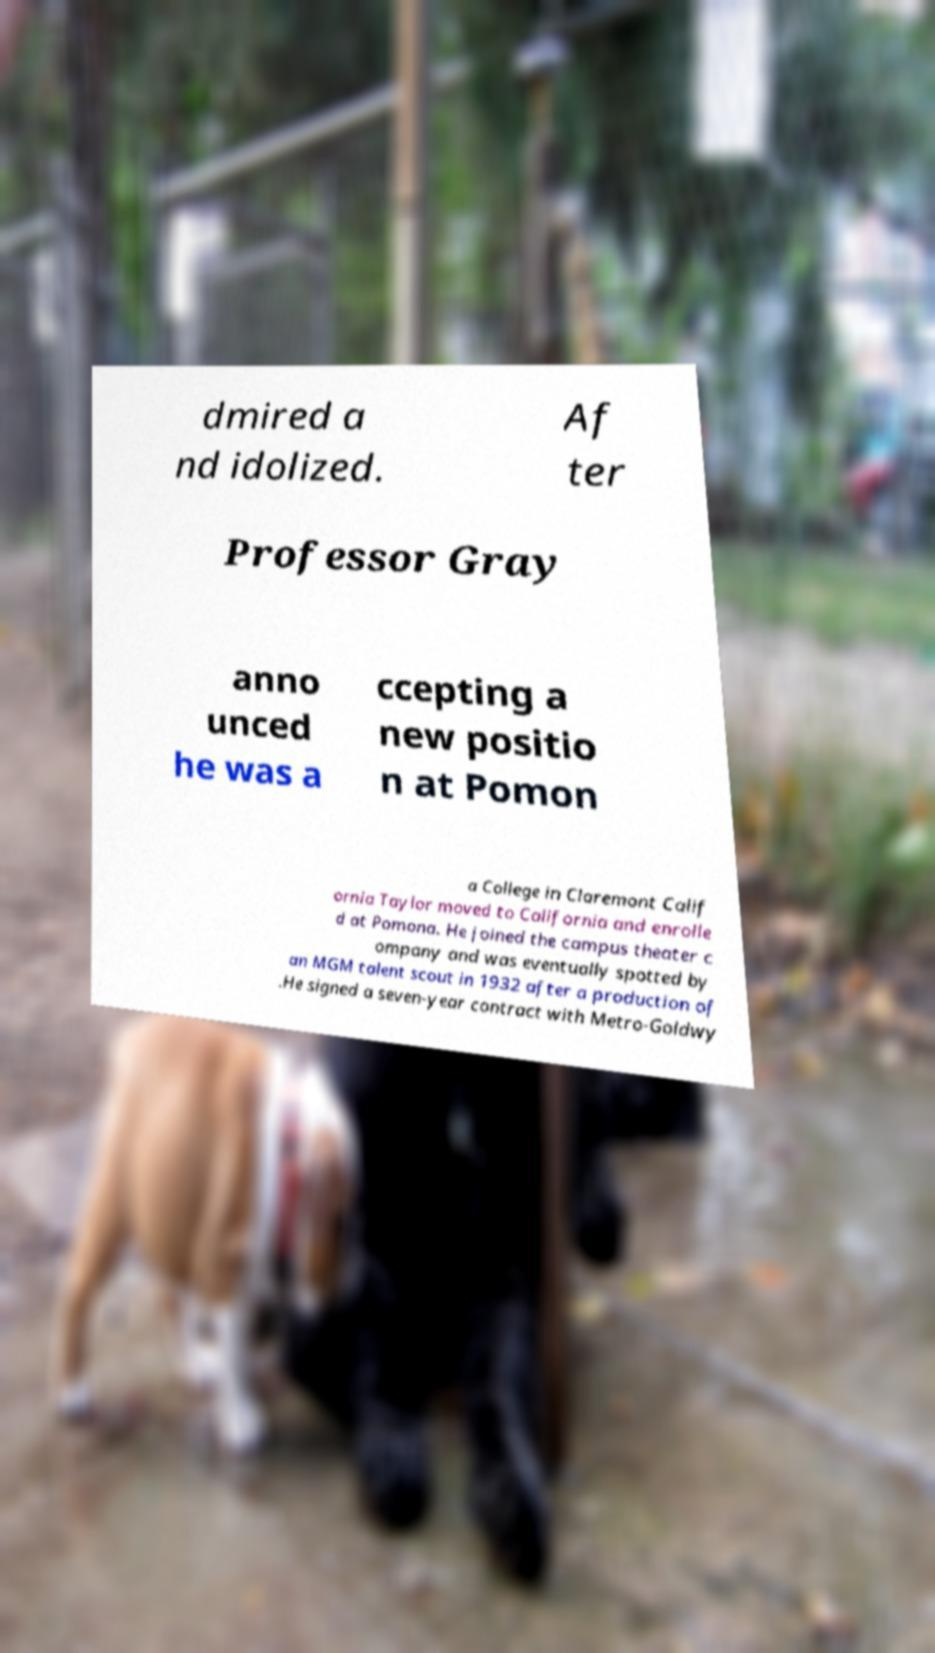There's text embedded in this image that I need extracted. Can you transcribe it verbatim? dmired a nd idolized. Af ter Professor Gray anno unced he was a ccepting a new positio n at Pomon a College in Claremont Calif ornia Taylor moved to California and enrolle d at Pomona. He joined the campus theater c ompany and was eventually spotted by an MGM talent scout in 1932 after a production of .He signed a seven-year contract with Metro-Goldwy 